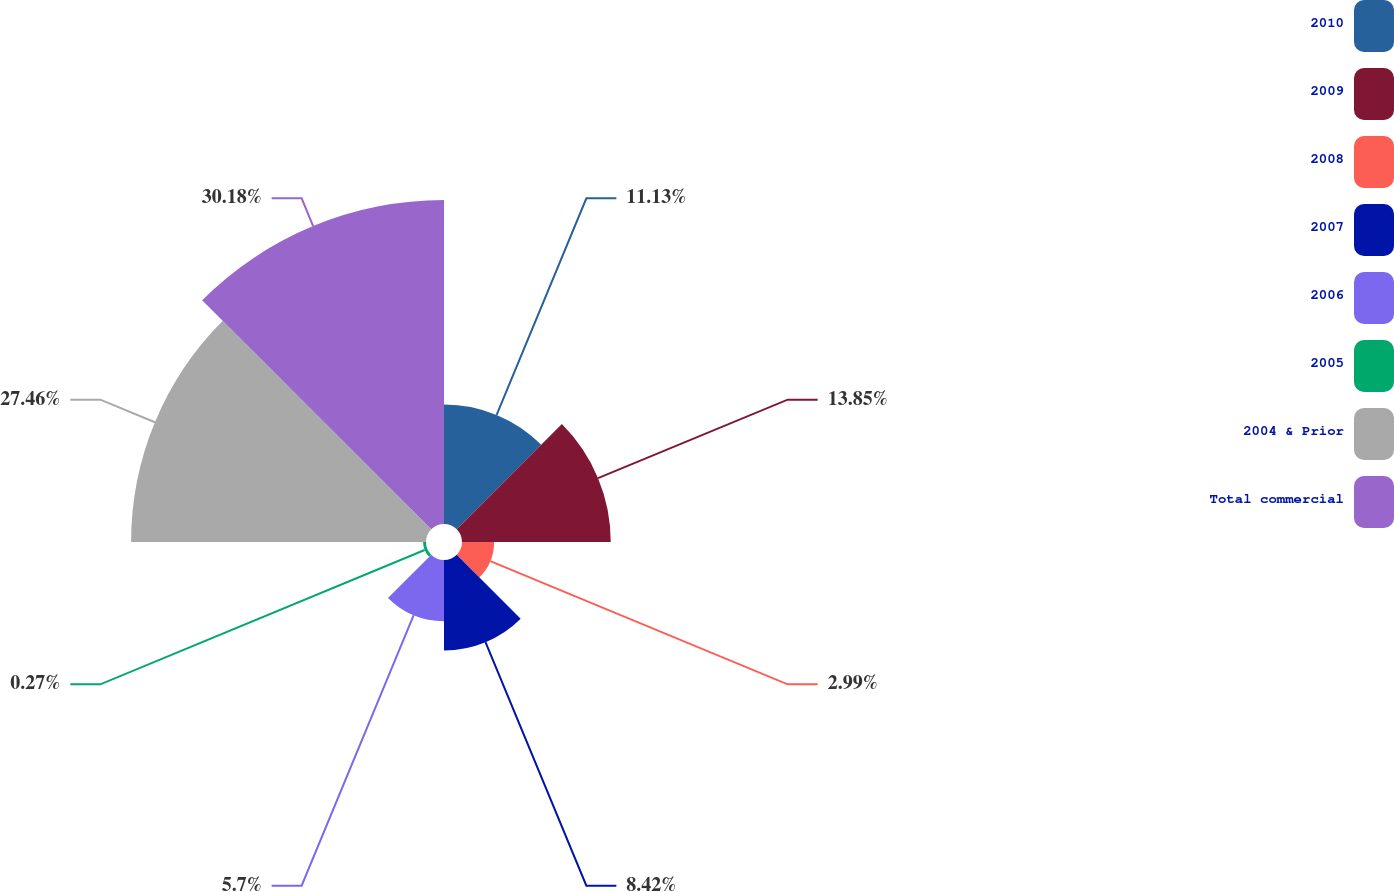Convert chart. <chart><loc_0><loc_0><loc_500><loc_500><pie_chart><fcel>2010<fcel>2009<fcel>2008<fcel>2007<fcel>2006<fcel>2005<fcel>2004 & Prior<fcel>Total commercial<nl><fcel>11.13%<fcel>13.85%<fcel>2.99%<fcel>8.42%<fcel>5.7%<fcel>0.27%<fcel>27.46%<fcel>30.17%<nl></chart> 